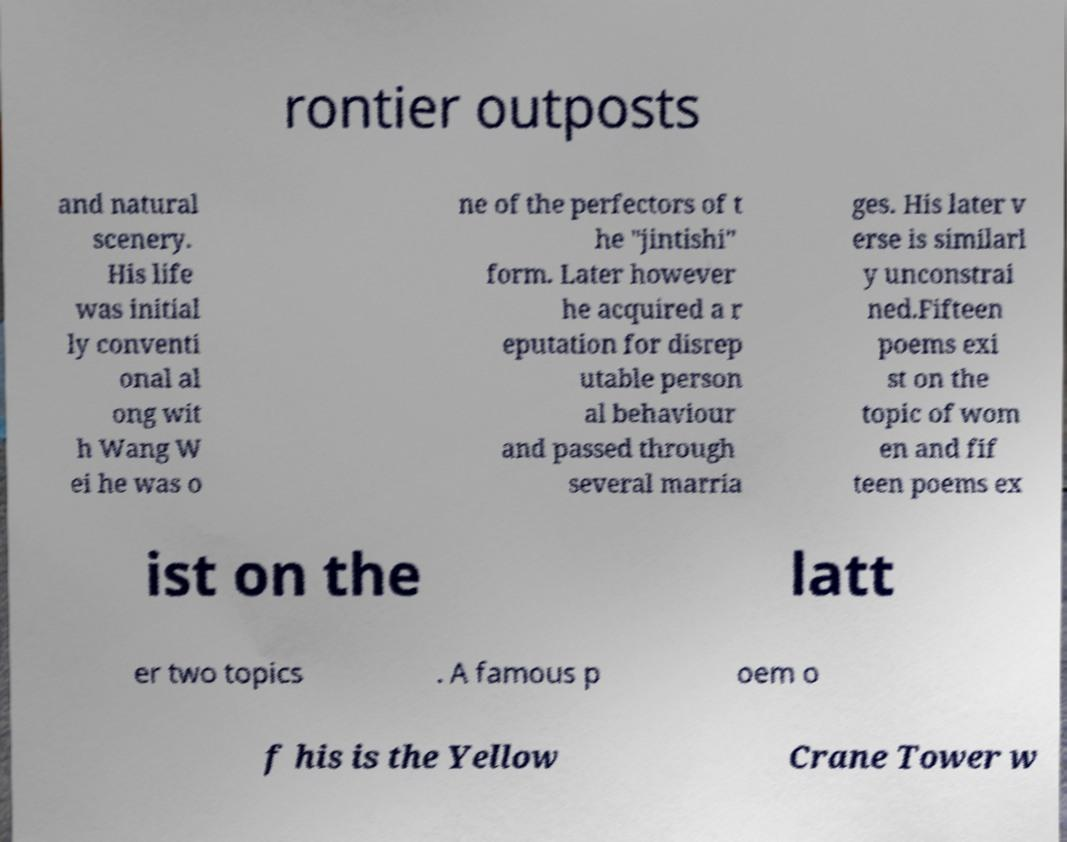For documentation purposes, I need the text within this image transcribed. Could you provide that? rontier outposts and natural scenery. His life was initial ly conventi onal al ong wit h Wang W ei he was o ne of the perfectors of t he "jintishi" form. Later however he acquired a r eputation for disrep utable person al behaviour and passed through several marria ges. His later v erse is similarl y unconstrai ned.Fifteen poems exi st on the topic of wom en and fif teen poems ex ist on the latt er two topics . A famous p oem o f his is the Yellow Crane Tower w 